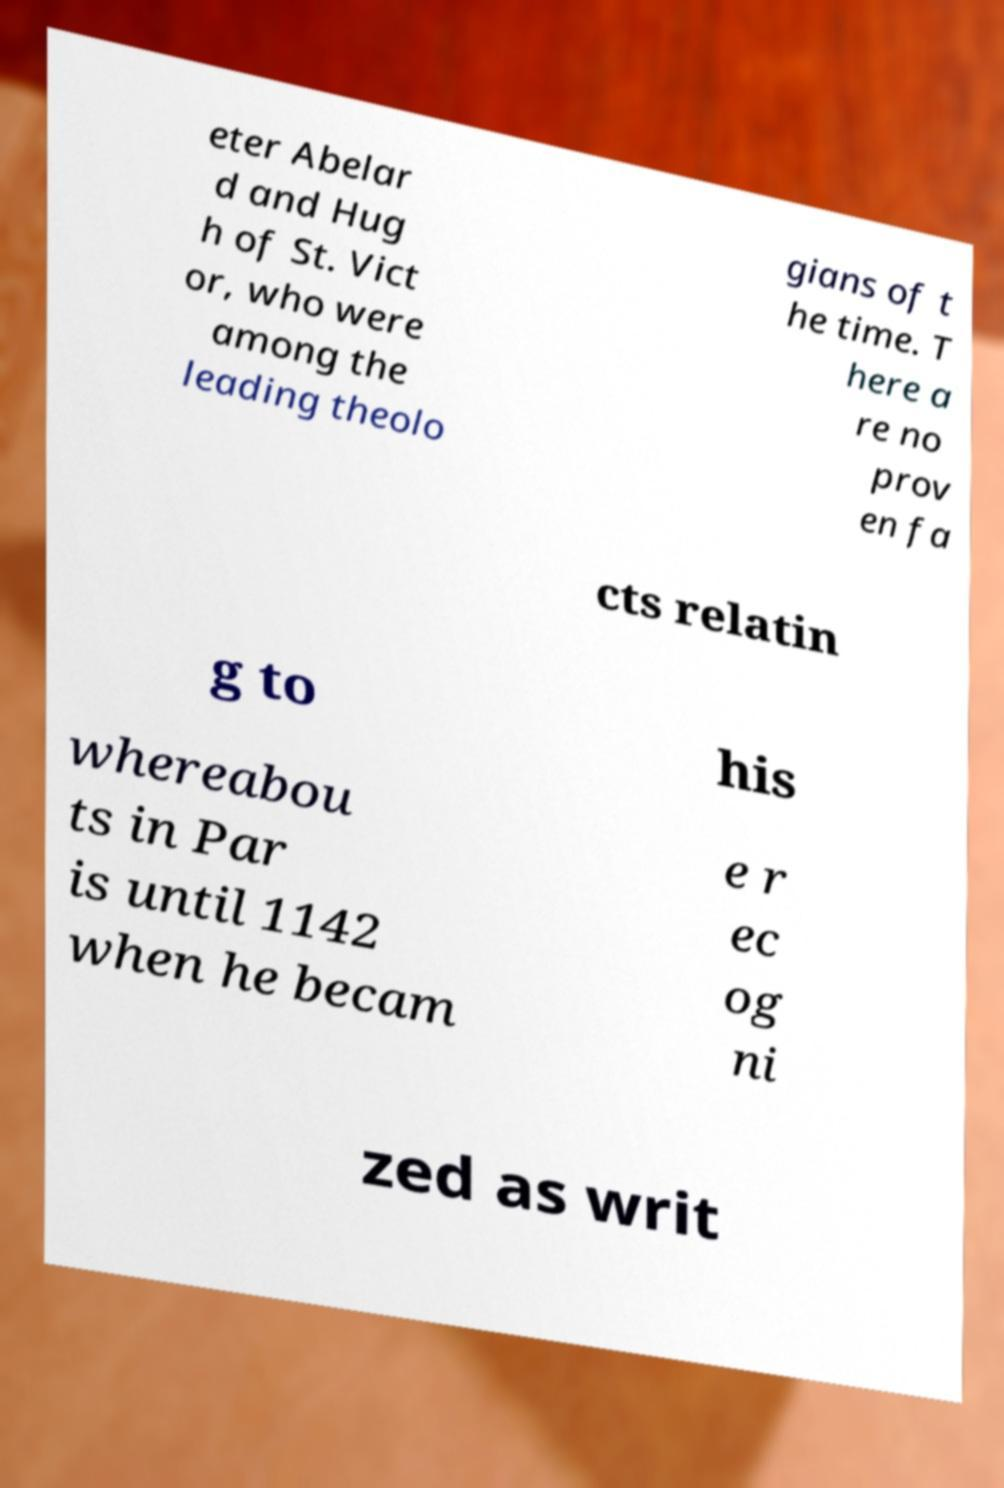Could you assist in decoding the text presented in this image and type it out clearly? eter Abelar d and Hug h of St. Vict or, who were among the leading theolo gians of t he time. T here a re no prov en fa cts relatin g to his whereabou ts in Par is until 1142 when he becam e r ec og ni zed as writ 